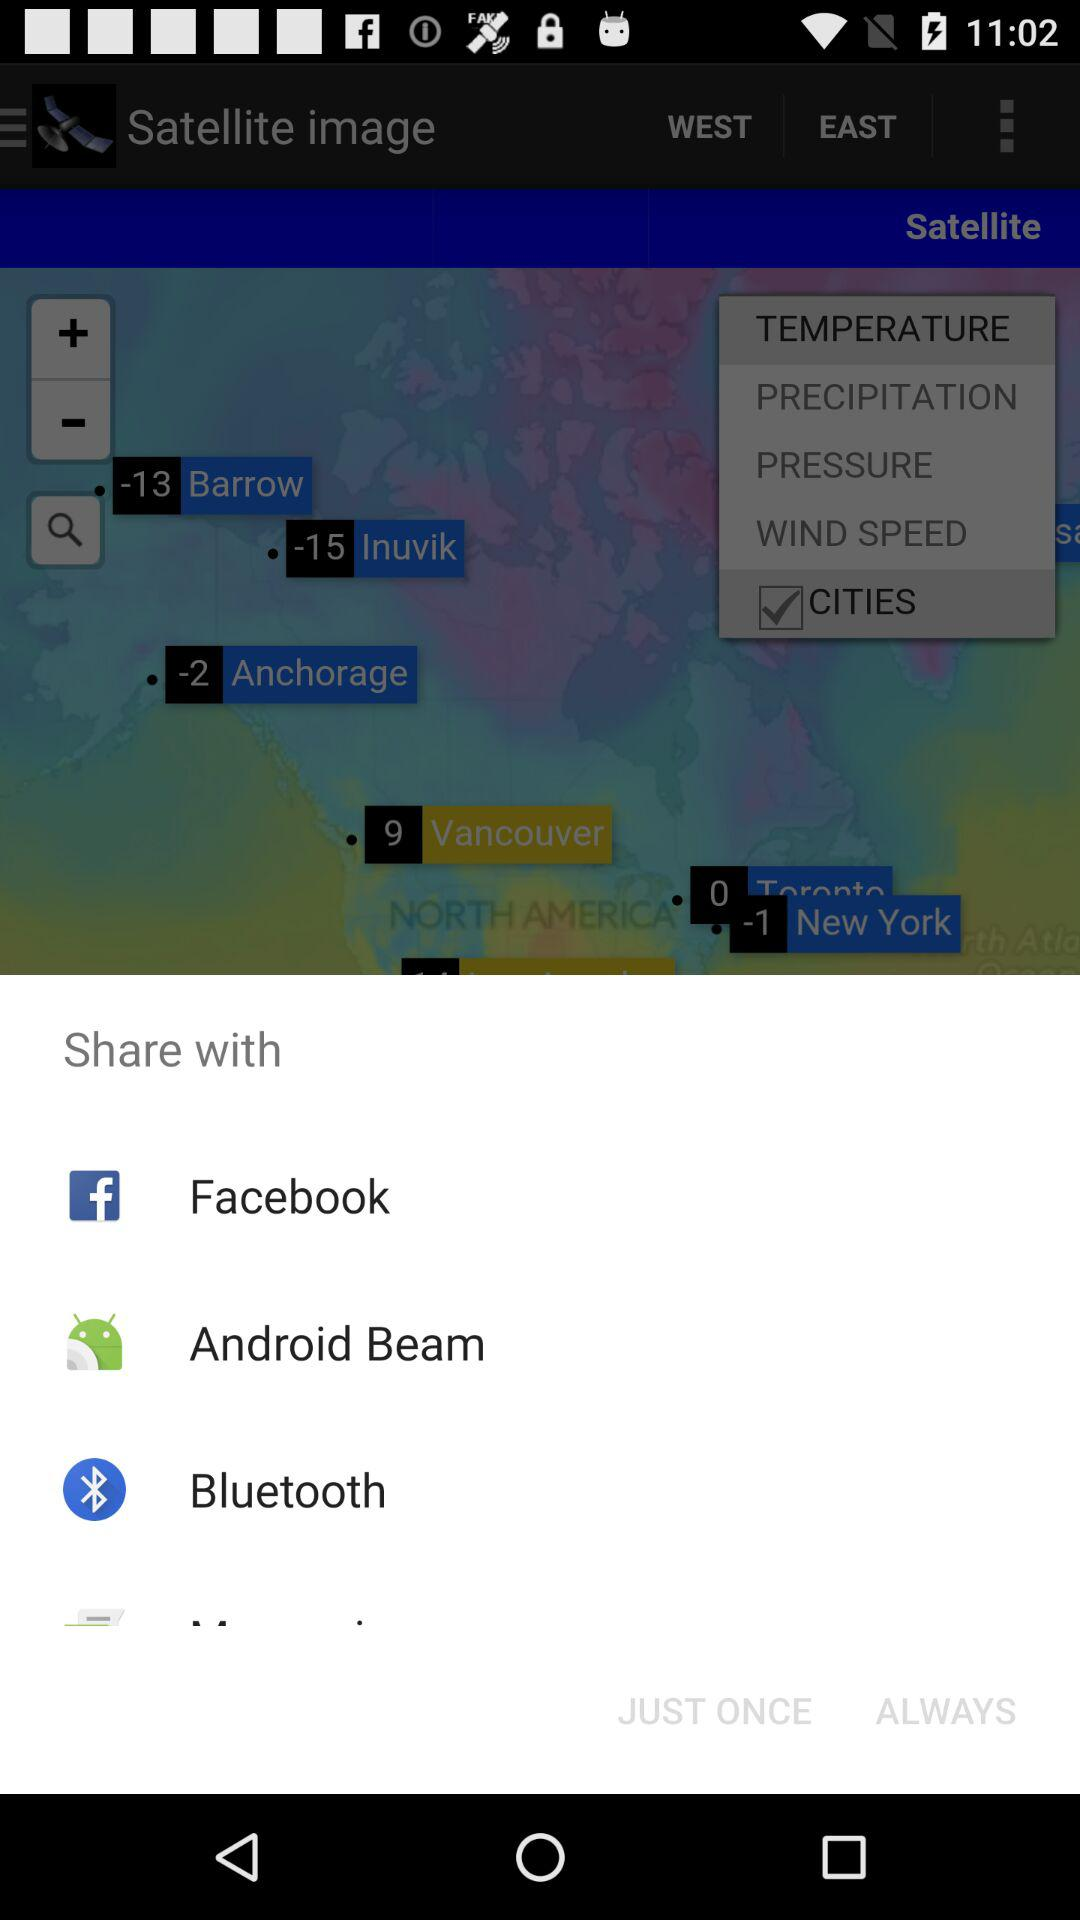How many degrees warmer is Barrow than Inuvik?
Answer the question using a single word or phrase. 2 